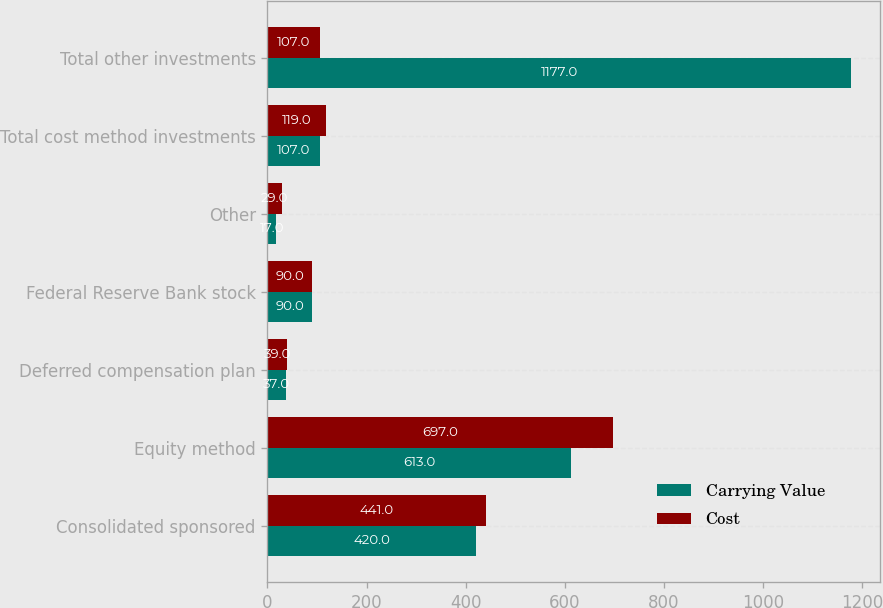Convert chart to OTSL. <chart><loc_0><loc_0><loc_500><loc_500><stacked_bar_chart><ecel><fcel>Consolidated sponsored<fcel>Equity method<fcel>Deferred compensation plan<fcel>Federal Reserve Bank stock<fcel>Other<fcel>Total cost method investments<fcel>Total other investments<nl><fcel>Carrying Value<fcel>420<fcel>613<fcel>37<fcel>90<fcel>17<fcel>107<fcel>1177<nl><fcel>Cost<fcel>441<fcel>697<fcel>39<fcel>90<fcel>29<fcel>119<fcel>107<nl></chart> 